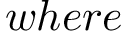<formula> <loc_0><loc_0><loc_500><loc_500>w h e r e</formula> 